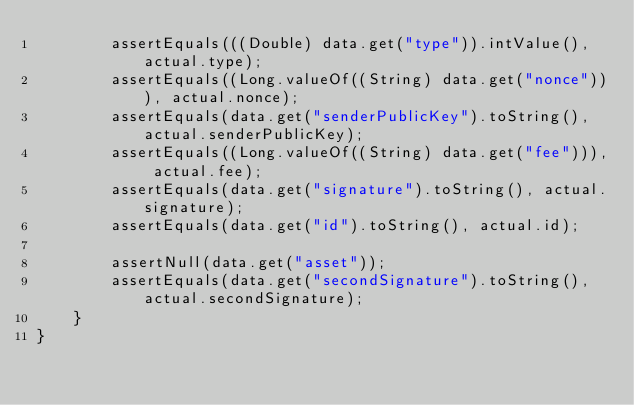Convert code to text. <code><loc_0><loc_0><loc_500><loc_500><_Java_>        assertEquals(((Double) data.get("type")).intValue(), actual.type);
        assertEquals((Long.valueOf((String) data.get("nonce"))), actual.nonce);
        assertEquals(data.get("senderPublicKey").toString(), actual.senderPublicKey);
        assertEquals((Long.valueOf((String) data.get("fee"))), actual.fee);
        assertEquals(data.get("signature").toString(), actual.signature);
        assertEquals(data.get("id").toString(), actual.id);

        assertNull(data.get("asset"));
        assertEquals(data.get("secondSignature").toString(), actual.secondSignature);
    }
}
</code> 